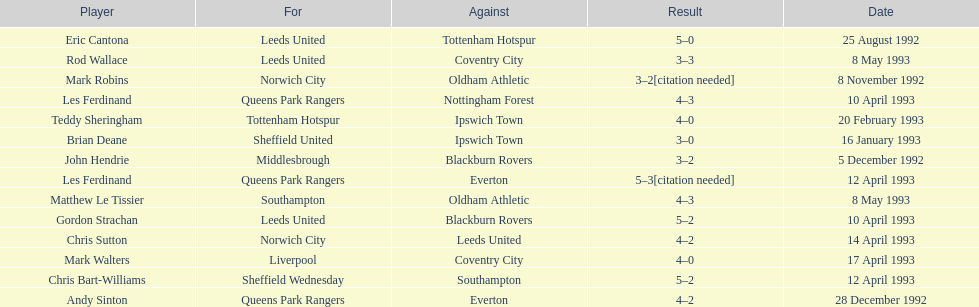Name the players for tottenham hotspur. Teddy Sheringham. 